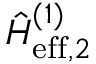<formula> <loc_0><loc_0><loc_500><loc_500>\hat { H } _ { e f f , 2 } ^ { ( 1 ) }</formula> 